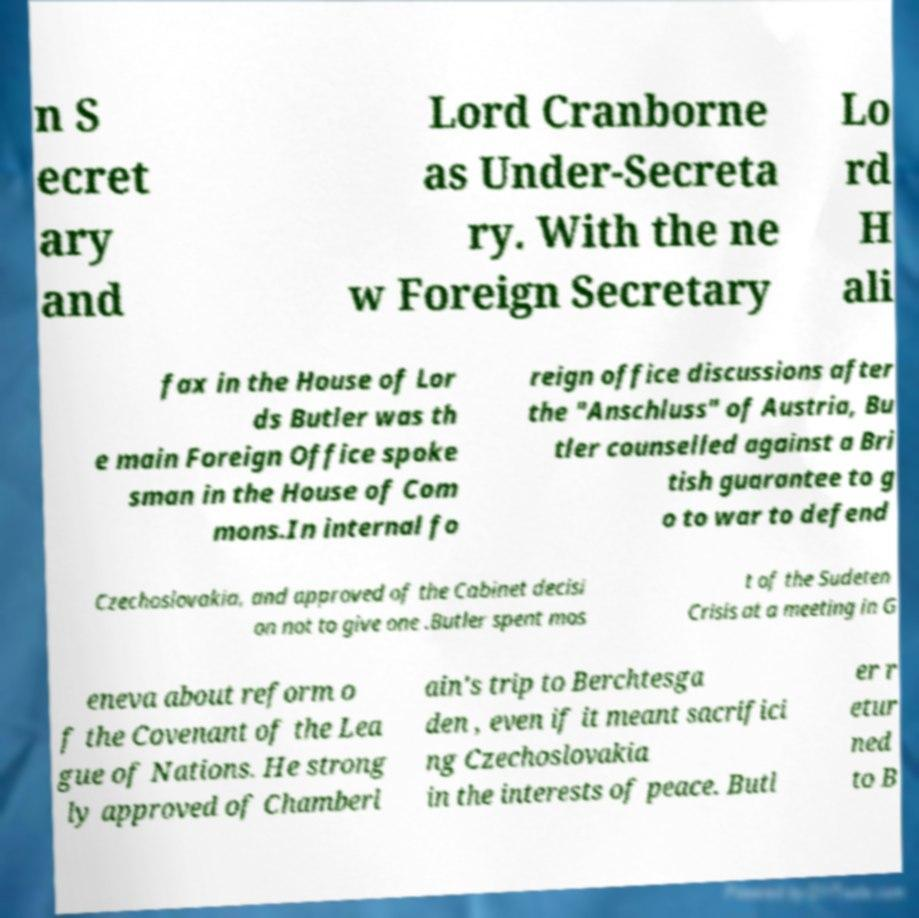What messages or text are displayed in this image? I need them in a readable, typed format. n S ecret ary and Lord Cranborne as Under-Secreta ry. With the ne w Foreign Secretary Lo rd H ali fax in the House of Lor ds Butler was th e main Foreign Office spoke sman in the House of Com mons.In internal fo reign office discussions after the "Anschluss" of Austria, Bu tler counselled against a Bri tish guarantee to g o to war to defend Czechoslovakia, and approved of the Cabinet decisi on not to give one .Butler spent mos t of the Sudeten Crisis at a meeting in G eneva about reform o f the Covenant of the Lea gue of Nations. He strong ly approved of Chamberl ain's trip to Berchtesga den , even if it meant sacrifici ng Czechoslovakia in the interests of peace. Butl er r etur ned to B 